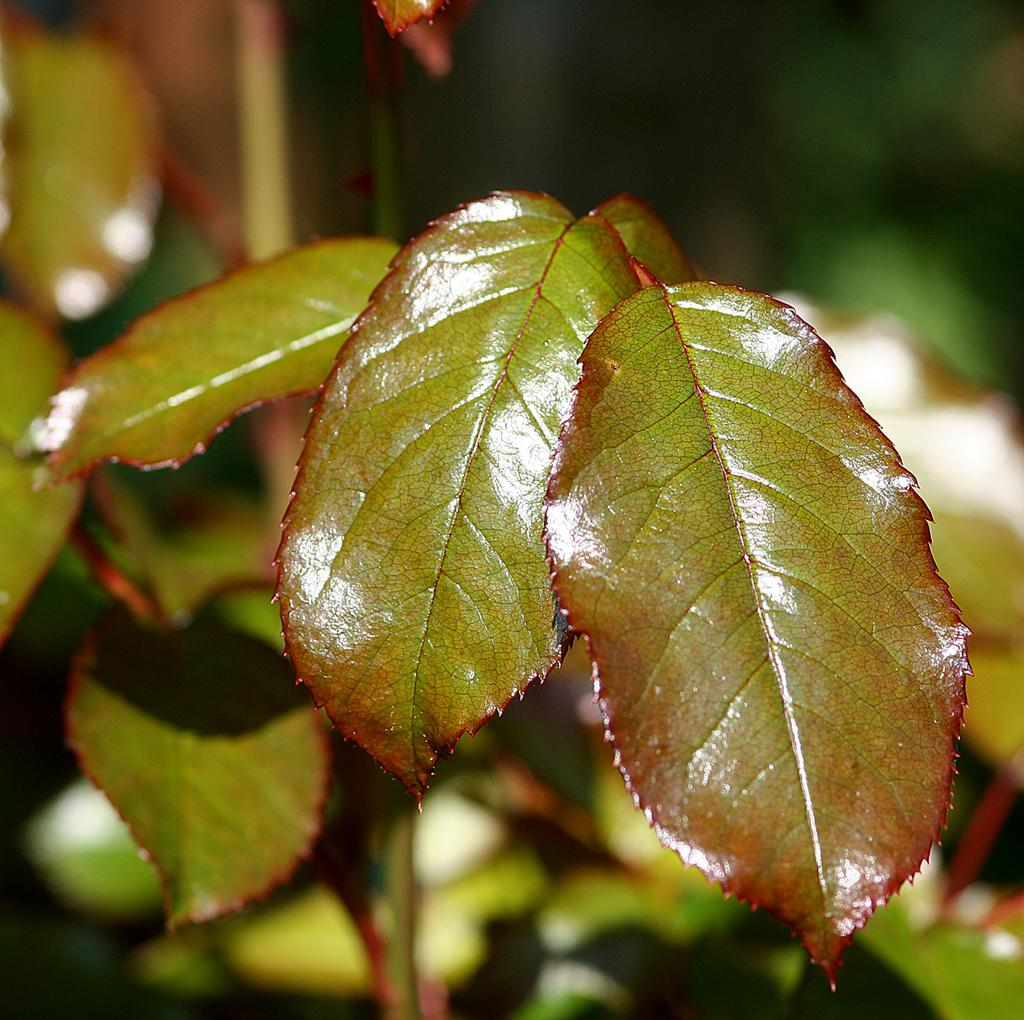What is located in the middle of the picture? There are leaves in the middle of the picture. Can you describe the background of the image? The background of the image is blurred. How does the water flow in the image? There is no water present in the image; it only features leaves and a blurred background. 